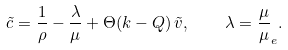<formula> <loc_0><loc_0><loc_500><loc_500>\tilde { c } = \frac { 1 } { \rho } - \frac { \lambda } { \mu } + \Theta ( k - Q ) \, \tilde { v } , \quad \lambda = \frac { \mu } { \mu } _ { e } .</formula> 